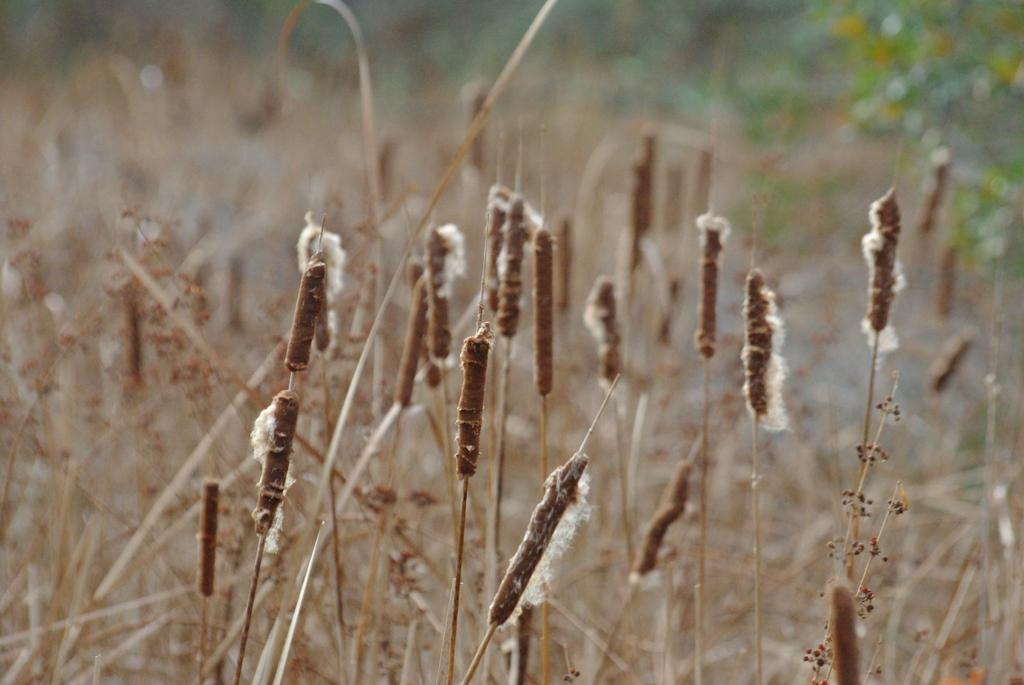What type of vegetation is in the center of the image? There is dry grass in the center of the image. What type of stage is visible in the image? There is no stage present in the image; it features dry grass in the center. How does the dry grass move or shake in the image? The dry grass does not move or shake in the image; it is stationary. 